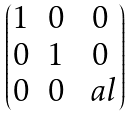<formula> <loc_0><loc_0><loc_500><loc_500>\begin{pmatrix} 1 & 0 & 0 \\ 0 & 1 & 0 \\ 0 & 0 & \ a l \end{pmatrix}</formula> 